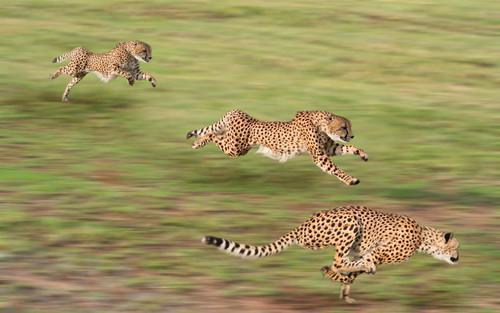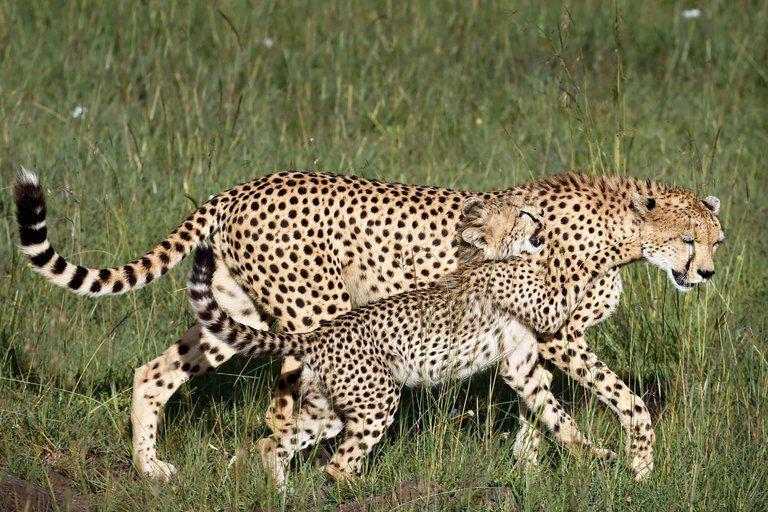The first image is the image on the left, the second image is the image on the right. For the images displayed, is the sentence "The same number of cheetahs are present in the left and right images." factually correct? Answer yes or no. No. 